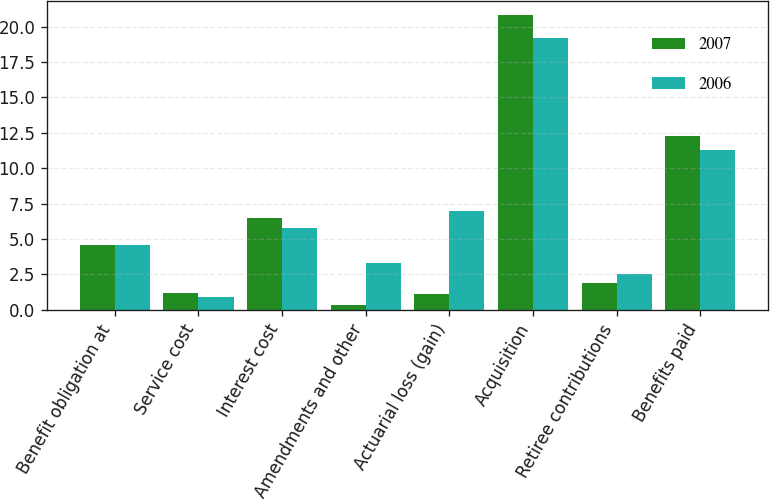Convert chart. <chart><loc_0><loc_0><loc_500><loc_500><stacked_bar_chart><ecel><fcel>Benefit obligation at<fcel>Service cost<fcel>Interest cost<fcel>Amendments and other<fcel>Actuarial loss (gain)<fcel>Acquisition<fcel>Retiree contributions<fcel>Benefits paid<nl><fcel>2007<fcel>4.55<fcel>1.2<fcel>6.5<fcel>0.3<fcel>1.1<fcel>20.8<fcel>1.9<fcel>12.3<nl><fcel>2006<fcel>4.55<fcel>0.9<fcel>5.8<fcel>3.3<fcel>7<fcel>19.2<fcel>2.5<fcel>11.3<nl></chart> 